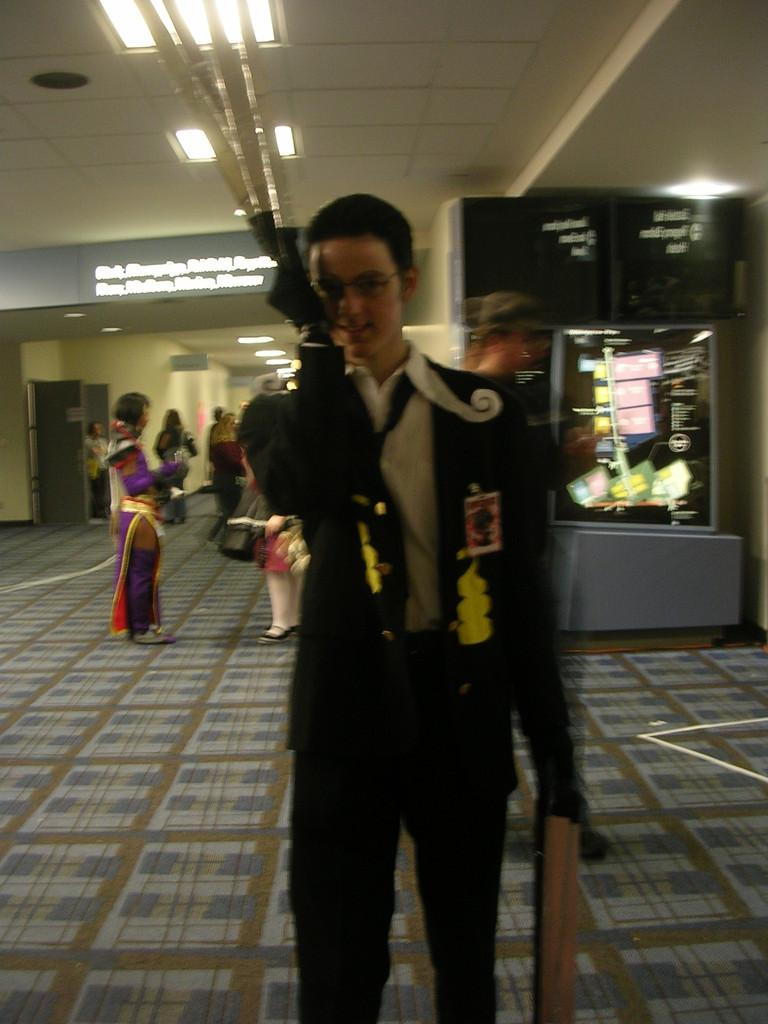What is the person in the image doing? The person is standing and holding objects in the image. Can you describe the setting in the background of the image? There is a group of people standing, lights, doors, and other unspecified items in the background of the image. What type of flooring is visible in the image? There is a carpet visible in the image. How many dogs are visible in the image? There are no dogs present in the image. What color is the ladybug on the person's shoulder in the image? There is no ladybug present on the person's shoulder or anywhere else in the image. 